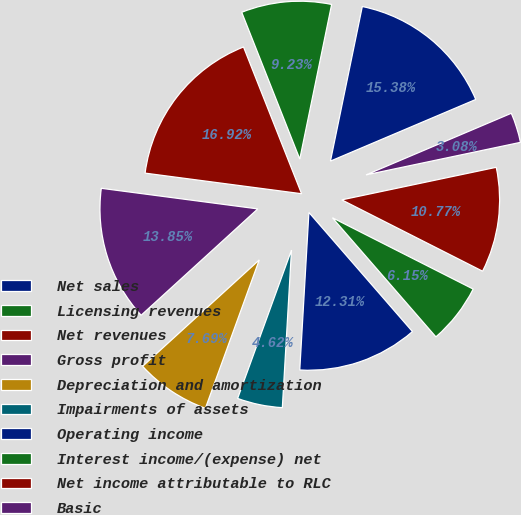Convert chart. <chart><loc_0><loc_0><loc_500><loc_500><pie_chart><fcel>Net sales<fcel>Licensing revenues<fcel>Net revenues<fcel>Gross profit<fcel>Depreciation and amortization<fcel>Impairments of assets<fcel>Operating income<fcel>Interest income/(expense) net<fcel>Net income attributable to RLC<fcel>Basic<nl><fcel>15.38%<fcel>9.23%<fcel>16.92%<fcel>13.85%<fcel>7.69%<fcel>4.62%<fcel>12.31%<fcel>6.15%<fcel>10.77%<fcel>3.08%<nl></chart> 